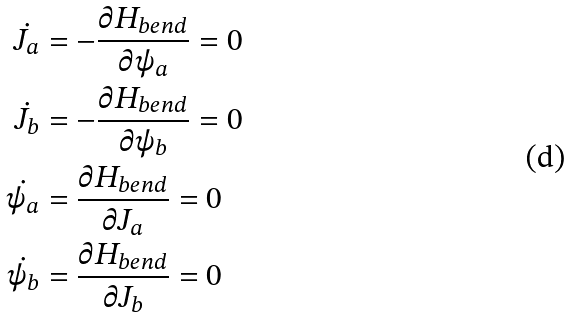Convert formula to latex. <formula><loc_0><loc_0><loc_500><loc_500>\dot { J _ { a } } & = - \frac { \partial H _ { b e n d } } { \partial \psi _ { a } } = 0 \\ \dot { J _ { b } } & = - \frac { \partial H _ { b e n d } } { \partial \psi _ { b } } = 0 \\ \dot { \psi _ { a } } & = \frac { \partial H _ { b e n d } } { \partial J _ { a } } = 0 \\ \dot { \psi _ { b } } & = \frac { \partial H _ { b e n d } } { \partial J _ { b } } = 0</formula> 